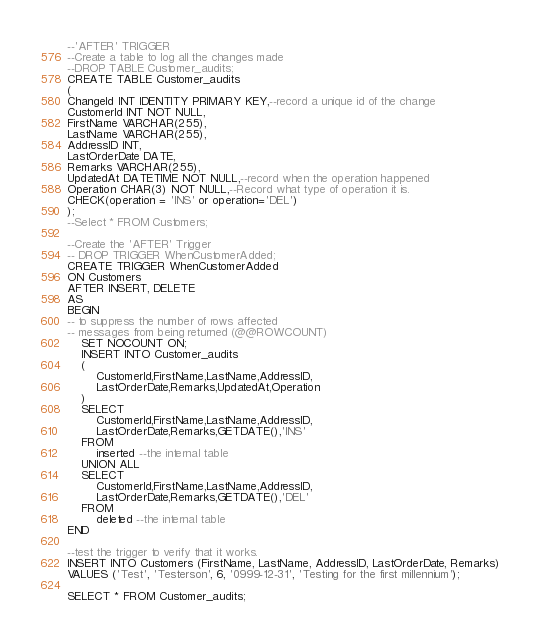<code> <loc_0><loc_0><loc_500><loc_500><_SQL_>--'AFTER' TRIGGER
--Create a table to log all the changes made
--DROP TABLE Customer_audits;
CREATE TABLE Customer_audits
(
ChangeId INT IDENTITY PRIMARY KEY,--record a unique id of the change
CustomerId INT NOT NULL,
FirstName VARCHAR(255),
LastName VARCHAR(255),
AddressID INT,
LastOrderDate DATE,
Remarks VARCHAR(255),
UpdatedAt DATETIME NOT NULL,--record when the operation happened
Operation CHAR(3) NOT NULL,--Record what type of operation it is.
CHECK(operation = 'INS' or operation='DEL')
);
--Select * FROM Customers;

--Create the 'AFTER' Trigger
-- DROP TRIGGER WhenCustomerAdded;
CREATE TRIGGER WhenCustomerAdded
ON Customers
AFTER INSERT, DELETE
AS 
BEGIN
-- to suppress the number of rows affected 
-- messages from being returned (@@ROWCOUNT)
	SET NOCOUNT ON;
	INSERT INTO Customer_audits
	(
		CustomerId,FirstName,LastName,AddressID,
		LastOrderDate,Remarks,UpdatedAt,Operation
	)
	SELECT
		CustomerId,FirstName,LastName,AddressID,
		LastOrderDate,Remarks,GETDATE(),'INS'
	FROM
		inserted --the internal table
	UNION ALL
	SELECT
		CustomerId,FirstName,LastName,AddressID,
		LastOrderDate,Remarks,GETDATE(),'DEL'
	FROM
		deleted --the internal table
END

--test the trigger to verify that it works.
INSERT INTO Customers (FirstName, LastName, AddressID, LastOrderDate, Remarks) 
VALUES ('Test', 'Testerson', 6, '0999-12-31', 'Testing for the first millennium');

SELECT * FROM Customer_audits;

</code> 